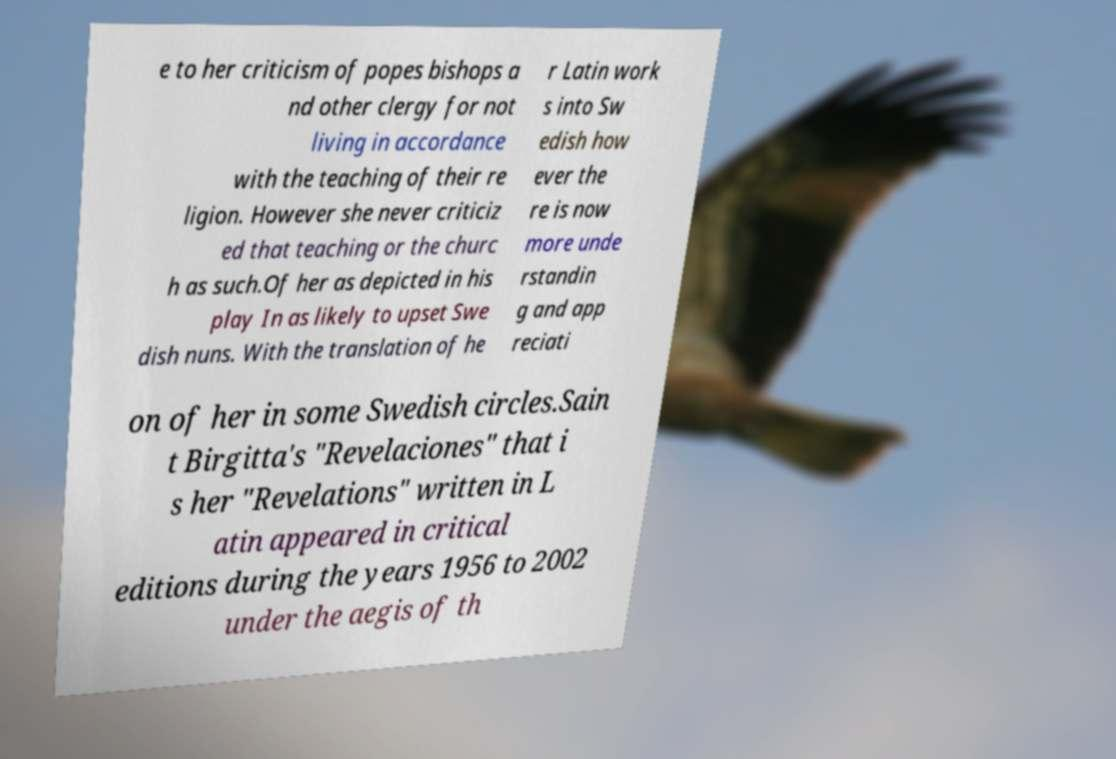Could you assist in decoding the text presented in this image and type it out clearly? e to her criticism of popes bishops a nd other clergy for not living in accordance with the teaching of their re ligion. However she never criticiz ed that teaching or the churc h as such.Of her as depicted in his play In as likely to upset Swe dish nuns. With the translation of he r Latin work s into Sw edish how ever the re is now more unde rstandin g and app reciati on of her in some Swedish circles.Sain t Birgitta's "Revelaciones" that i s her "Revelations" written in L atin appeared in critical editions during the years 1956 to 2002 under the aegis of th 